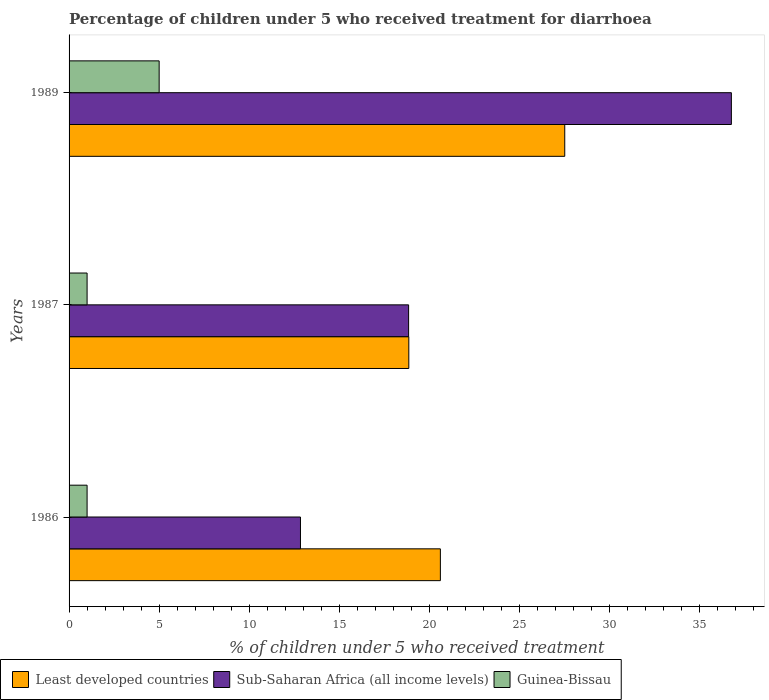How many different coloured bars are there?
Keep it short and to the point. 3. Are the number of bars per tick equal to the number of legend labels?
Provide a succinct answer. Yes. Are the number of bars on each tick of the Y-axis equal?
Ensure brevity in your answer.  Yes. What is the percentage of children who received treatment for diarrhoea  in Sub-Saharan Africa (all income levels) in 1987?
Make the answer very short. 18.85. Across all years, what is the maximum percentage of children who received treatment for diarrhoea  in Guinea-Bissau?
Your response must be concise. 5. Across all years, what is the minimum percentage of children who received treatment for diarrhoea  in Guinea-Bissau?
Your answer should be compact. 1. In which year was the percentage of children who received treatment for diarrhoea  in Guinea-Bissau maximum?
Make the answer very short. 1989. What is the total percentage of children who received treatment for diarrhoea  in Sub-Saharan Africa (all income levels) in the graph?
Offer a very short reply. 68.45. What is the difference between the percentage of children who received treatment for diarrhoea  in Sub-Saharan Africa (all income levels) in 1987 and the percentage of children who received treatment for diarrhoea  in Guinea-Bissau in 1986?
Offer a terse response. 17.85. What is the average percentage of children who received treatment for diarrhoea  in Least developed countries per year?
Provide a short and direct response. 22.33. In the year 1987, what is the difference between the percentage of children who received treatment for diarrhoea  in Guinea-Bissau and percentage of children who received treatment for diarrhoea  in Sub-Saharan Africa (all income levels)?
Provide a short and direct response. -17.85. In how many years, is the percentage of children who received treatment for diarrhoea  in Guinea-Bissau greater than 14 %?
Provide a succinct answer. 0. What is the ratio of the percentage of children who received treatment for diarrhoea  in Guinea-Bissau in 1987 to that in 1989?
Provide a short and direct response. 0.2. What is the difference between the highest and the lowest percentage of children who received treatment for diarrhoea  in Least developed countries?
Offer a terse response. 8.65. What does the 2nd bar from the top in 1986 represents?
Your response must be concise. Sub-Saharan Africa (all income levels). What does the 2nd bar from the bottom in 1986 represents?
Your answer should be very brief. Sub-Saharan Africa (all income levels). How many bars are there?
Provide a succinct answer. 9. How many years are there in the graph?
Ensure brevity in your answer.  3. What is the difference between two consecutive major ticks on the X-axis?
Your answer should be compact. 5. Does the graph contain any zero values?
Provide a short and direct response. No. Does the graph contain grids?
Provide a short and direct response. No. How are the legend labels stacked?
Keep it short and to the point. Horizontal. What is the title of the graph?
Provide a succinct answer. Percentage of children under 5 who received treatment for diarrhoea. What is the label or title of the X-axis?
Provide a succinct answer. % of children under 5 who received treatment. What is the label or title of the Y-axis?
Your response must be concise. Years. What is the % of children under 5 who received treatment of Least developed countries in 1986?
Your response must be concise. 20.61. What is the % of children under 5 who received treatment of Sub-Saharan Africa (all income levels) in 1986?
Keep it short and to the point. 12.84. What is the % of children under 5 who received treatment of Least developed countries in 1987?
Your answer should be very brief. 18.86. What is the % of children under 5 who received treatment of Sub-Saharan Africa (all income levels) in 1987?
Provide a short and direct response. 18.85. What is the % of children under 5 who received treatment of Least developed countries in 1989?
Your answer should be compact. 27.51. What is the % of children under 5 who received treatment of Sub-Saharan Africa (all income levels) in 1989?
Offer a very short reply. 36.76. What is the % of children under 5 who received treatment of Guinea-Bissau in 1989?
Provide a succinct answer. 5. Across all years, what is the maximum % of children under 5 who received treatment of Least developed countries?
Give a very brief answer. 27.51. Across all years, what is the maximum % of children under 5 who received treatment of Sub-Saharan Africa (all income levels)?
Provide a short and direct response. 36.76. Across all years, what is the maximum % of children under 5 who received treatment in Guinea-Bissau?
Offer a very short reply. 5. Across all years, what is the minimum % of children under 5 who received treatment of Least developed countries?
Ensure brevity in your answer.  18.86. Across all years, what is the minimum % of children under 5 who received treatment of Sub-Saharan Africa (all income levels)?
Offer a terse response. 12.84. Across all years, what is the minimum % of children under 5 who received treatment of Guinea-Bissau?
Provide a succinct answer. 1. What is the total % of children under 5 who received treatment in Least developed countries in the graph?
Ensure brevity in your answer.  66.98. What is the total % of children under 5 who received treatment of Sub-Saharan Africa (all income levels) in the graph?
Make the answer very short. 68.45. What is the total % of children under 5 who received treatment in Guinea-Bissau in the graph?
Keep it short and to the point. 7. What is the difference between the % of children under 5 who received treatment in Least developed countries in 1986 and that in 1987?
Keep it short and to the point. 1.75. What is the difference between the % of children under 5 who received treatment of Sub-Saharan Africa (all income levels) in 1986 and that in 1987?
Your answer should be compact. -6. What is the difference between the % of children under 5 who received treatment in Guinea-Bissau in 1986 and that in 1987?
Your response must be concise. 0. What is the difference between the % of children under 5 who received treatment of Least developed countries in 1986 and that in 1989?
Ensure brevity in your answer.  -6.9. What is the difference between the % of children under 5 who received treatment in Sub-Saharan Africa (all income levels) in 1986 and that in 1989?
Provide a short and direct response. -23.92. What is the difference between the % of children under 5 who received treatment of Guinea-Bissau in 1986 and that in 1989?
Provide a succinct answer. -4. What is the difference between the % of children under 5 who received treatment in Least developed countries in 1987 and that in 1989?
Give a very brief answer. -8.65. What is the difference between the % of children under 5 who received treatment in Sub-Saharan Africa (all income levels) in 1987 and that in 1989?
Your answer should be very brief. -17.91. What is the difference between the % of children under 5 who received treatment in Least developed countries in 1986 and the % of children under 5 who received treatment in Sub-Saharan Africa (all income levels) in 1987?
Your answer should be compact. 1.76. What is the difference between the % of children under 5 who received treatment in Least developed countries in 1986 and the % of children under 5 who received treatment in Guinea-Bissau in 1987?
Make the answer very short. 19.61. What is the difference between the % of children under 5 who received treatment in Sub-Saharan Africa (all income levels) in 1986 and the % of children under 5 who received treatment in Guinea-Bissau in 1987?
Make the answer very short. 11.84. What is the difference between the % of children under 5 who received treatment in Least developed countries in 1986 and the % of children under 5 who received treatment in Sub-Saharan Africa (all income levels) in 1989?
Your answer should be compact. -16.15. What is the difference between the % of children under 5 who received treatment of Least developed countries in 1986 and the % of children under 5 who received treatment of Guinea-Bissau in 1989?
Offer a terse response. 15.61. What is the difference between the % of children under 5 who received treatment in Sub-Saharan Africa (all income levels) in 1986 and the % of children under 5 who received treatment in Guinea-Bissau in 1989?
Your response must be concise. 7.84. What is the difference between the % of children under 5 who received treatment of Least developed countries in 1987 and the % of children under 5 who received treatment of Sub-Saharan Africa (all income levels) in 1989?
Your answer should be very brief. -17.9. What is the difference between the % of children under 5 who received treatment in Least developed countries in 1987 and the % of children under 5 who received treatment in Guinea-Bissau in 1989?
Provide a short and direct response. 13.86. What is the difference between the % of children under 5 who received treatment in Sub-Saharan Africa (all income levels) in 1987 and the % of children under 5 who received treatment in Guinea-Bissau in 1989?
Provide a short and direct response. 13.85. What is the average % of children under 5 who received treatment in Least developed countries per year?
Keep it short and to the point. 22.33. What is the average % of children under 5 who received treatment in Sub-Saharan Africa (all income levels) per year?
Offer a very short reply. 22.82. What is the average % of children under 5 who received treatment of Guinea-Bissau per year?
Offer a terse response. 2.33. In the year 1986, what is the difference between the % of children under 5 who received treatment in Least developed countries and % of children under 5 who received treatment in Sub-Saharan Africa (all income levels)?
Offer a very short reply. 7.76. In the year 1986, what is the difference between the % of children under 5 who received treatment in Least developed countries and % of children under 5 who received treatment in Guinea-Bissau?
Your response must be concise. 19.61. In the year 1986, what is the difference between the % of children under 5 who received treatment in Sub-Saharan Africa (all income levels) and % of children under 5 who received treatment in Guinea-Bissau?
Provide a succinct answer. 11.84. In the year 1987, what is the difference between the % of children under 5 who received treatment in Least developed countries and % of children under 5 who received treatment in Sub-Saharan Africa (all income levels)?
Give a very brief answer. 0.01. In the year 1987, what is the difference between the % of children under 5 who received treatment of Least developed countries and % of children under 5 who received treatment of Guinea-Bissau?
Keep it short and to the point. 17.86. In the year 1987, what is the difference between the % of children under 5 who received treatment of Sub-Saharan Africa (all income levels) and % of children under 5 who received treatment of Guinea-Bissau?
Your answer should be very brief. 17.85. In the year 1989, what is the difference between the % of children under 5 who received treatment of Least developed countries and % of children under 5 who received treatment of Sub-Saharan Africa (all income levels)?
Provide a short and direct response. -9.25. In the year 1989, what is the difference between the % of children under 5 who received treatment in Least developed countries and % of children under 5 who received treatment in Guinea-Bissau?
Offer a terse response. 22.51. In the year 1989, what is the difference between the % of children under 5 who received treatment of Sub-Saharan Africa (all income levels) and % of children under 5 who received treatment of Guinea-Bissau?
Offer a very short reply. 31.76. What is the ratio of the % of children under 5 who received treatment of Least developed countries in 1986 to that in 1987?
Your answer should be very brief. 1.09. What is the ratio of the % of children under 5 who received treatment of Sub-Saharan Africa (all income levels) in 1986 to that in 1987?
Your answer should be compact. 0.68. What is the ratio of the % of children under 5 who received treatment in Guinea-Bissau in 1986 to that in 1987?
Keep it short and to the point. 1. What is the ratio of the % of children under 5 who received treatment of Least developed countries in 1986 to that in 1989?
Provide a succinct answer. 0.75. What is the ratio of the % of children under 5 who received treatment in Sub-Saharan Africa (all income levels) in 1986 to that in 1989?
Provide a short and direct response. 0.35. What is the ratio of the % of children under 5 who received treatment of Guinea-Bissau in 1986 to that in 1989?
Provide a short and direct response. 0.2. What is the ratio of the % of children under 5 who received treatment of Least developed countries in 1987 to that in 1989?
Offer a terse response. 0.69. What is the ratio of the % of children under 5 who received treatment in Sub-Saharan Africa (all income levels) in 1987 to that in 1989?
Provide a short and direct response. 0.51. What is the ratio of the % of children under 5 who received treatment in Guinea-Bissau in 1987 to that in 1989?
Your answer should be very brief. 0.2. What is the difference between the highest and the second highest % of children under 5 who received treatment in Least developed countries?
Your answer should be compact. 6.9. What is the difference between the highest and the second highest % of children under 5 who received treatment of Sub-Saharan Africa (all income levels)?
Provide a short and direct response. 17.91. What is the difference between the highest and the second highest % of children under 5 who received treatment of Guinea-Bissau?
Provide a succinct answer. 4. What is the difference between the highest and the lowest % of children under 5 who received treatment of Least developed countries?
Your response must be concise. 8.65. What is the difference between the highest and the lowest % of children under 5 who received treatment in Sub-Saharan Africa (all income levels)?
Ensure brevity in your answer.  23.92. 